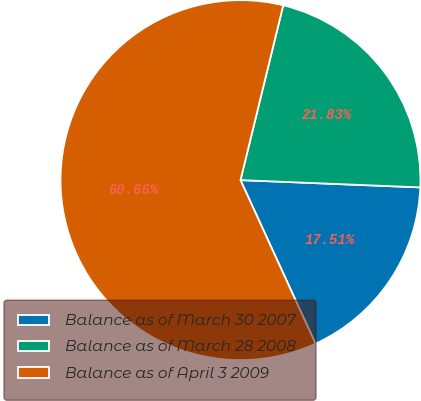Convert chart to OTSL. <chart><loc_0><loc_0><loc_500><loc_500><pie_chart><fcel>Balance as of March 30 2007<fcel>Balance as of March 28 2008<fcel>Balance as of April 3 2009<nl><fcel>17.51%<fcel>21.83%<fcel>60.66%<nl></chart> 